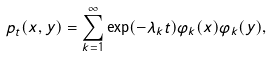<formula> <loc_0><loc_0><loc_500><loc_500>p _ { t } ( x , y ) = \sum _ { k = 1 } ^ { \infty } \exp ( - \lambda _ { k } t ) \varphi _ { k } ( x ) \varphi _ { k } ( y ) ,</formula> 